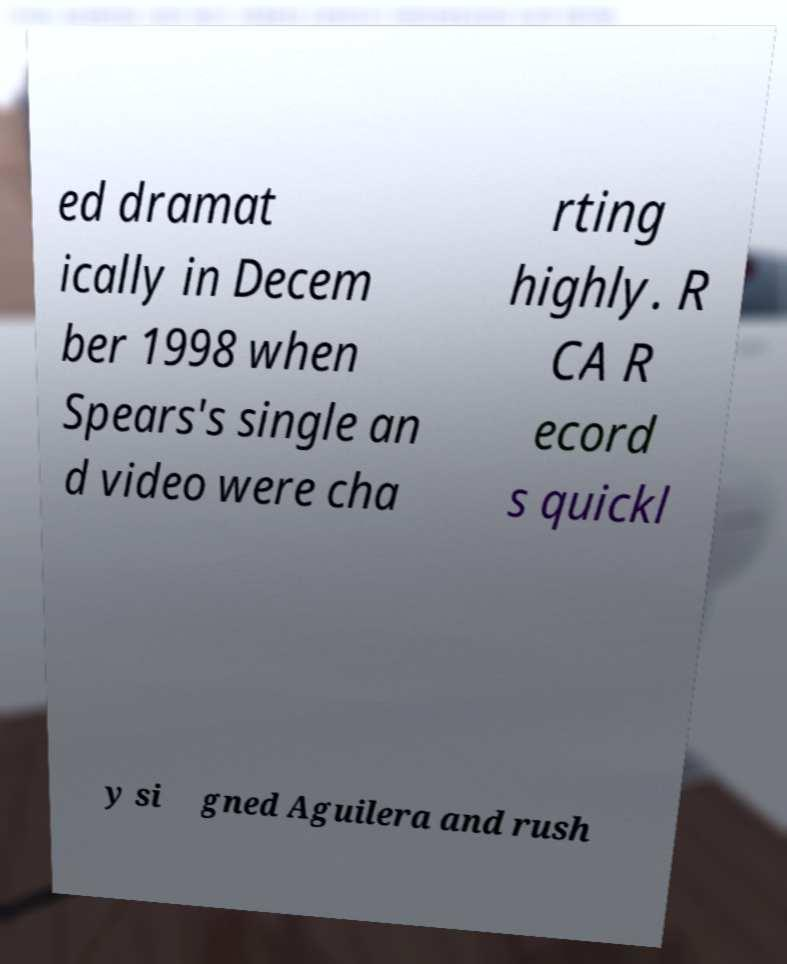Can you accurately transcribe the text from the provided image for me? ed dramat ically in Decem ber 1998 when Spears's single an d video were cha rting highly. R CA R ecord s quickl y si gned Aguilera and rush 